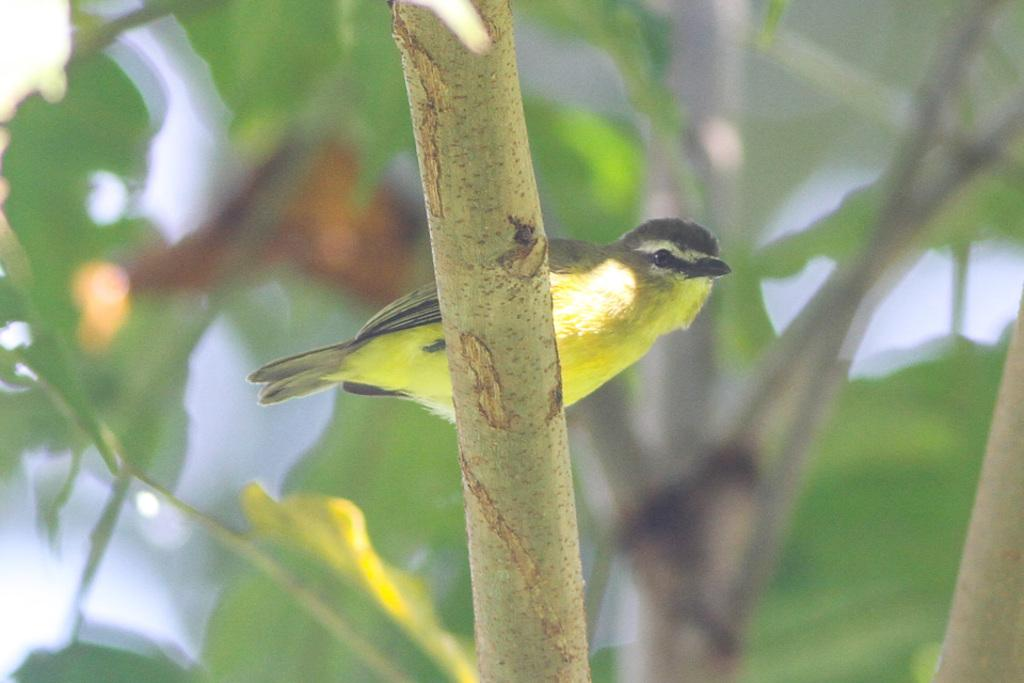What is the main subject in the center of the image? There is a branch in the center of the image. What is on the branch? There is a bird on the branch. Can you describe the bird's appearance? The bird has green and black colors. What else can be seen in the image? There is a tree in the image. What type of crayon is the bird using to draw on the branch? There is no crayon present in the image, and the bird is not drawing on the branch. 